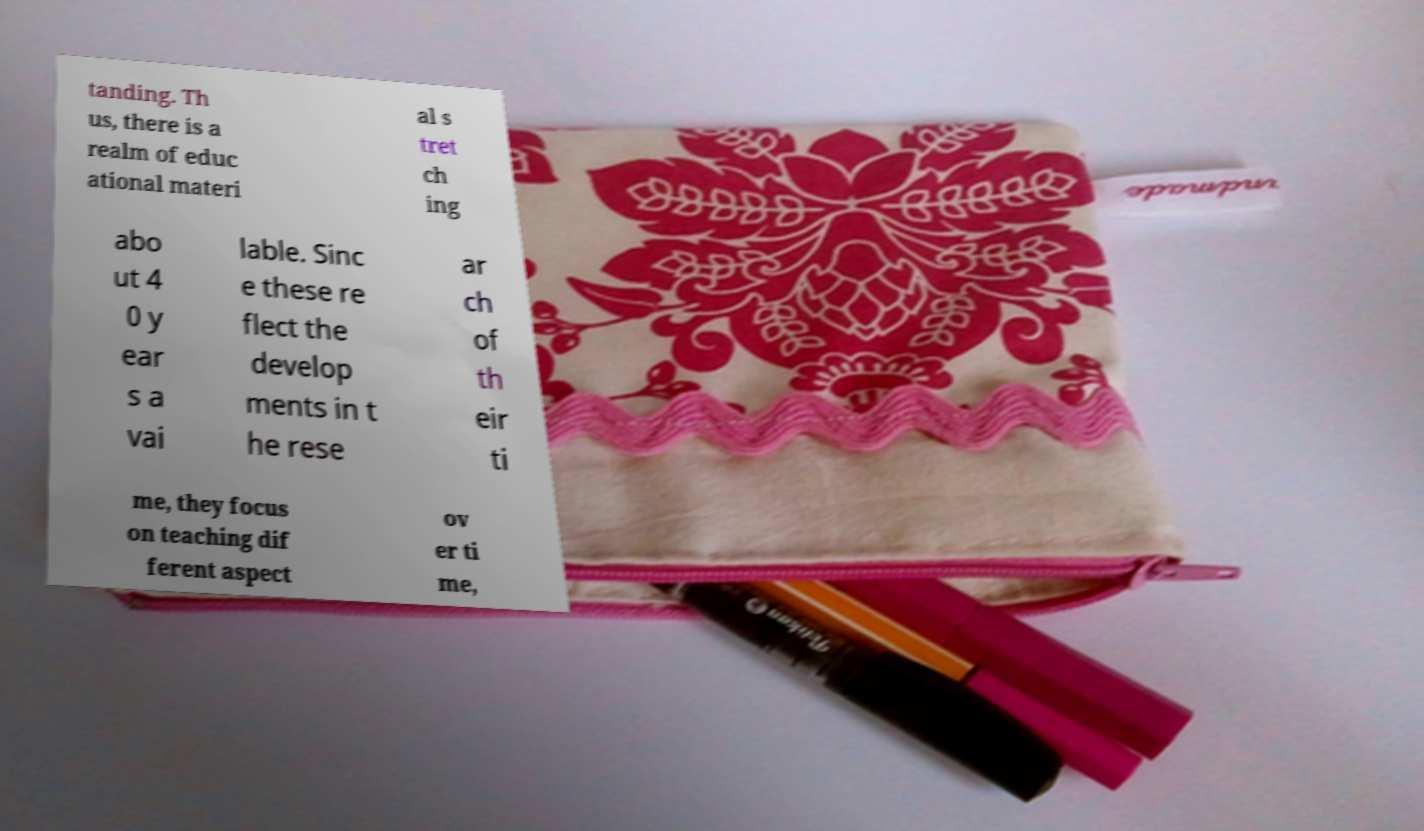I need the written content from this picture converted into text. Can you do that? tanding. Th us, there is a realm of educ ational materi al s tret ch ing abo ut 4 0 y ear s a vai lable. Sinc e these re flect the develop ments in t he rese ar ch of th eir ti me, they focus on teaching dif ferent aspect ov er ti me, 